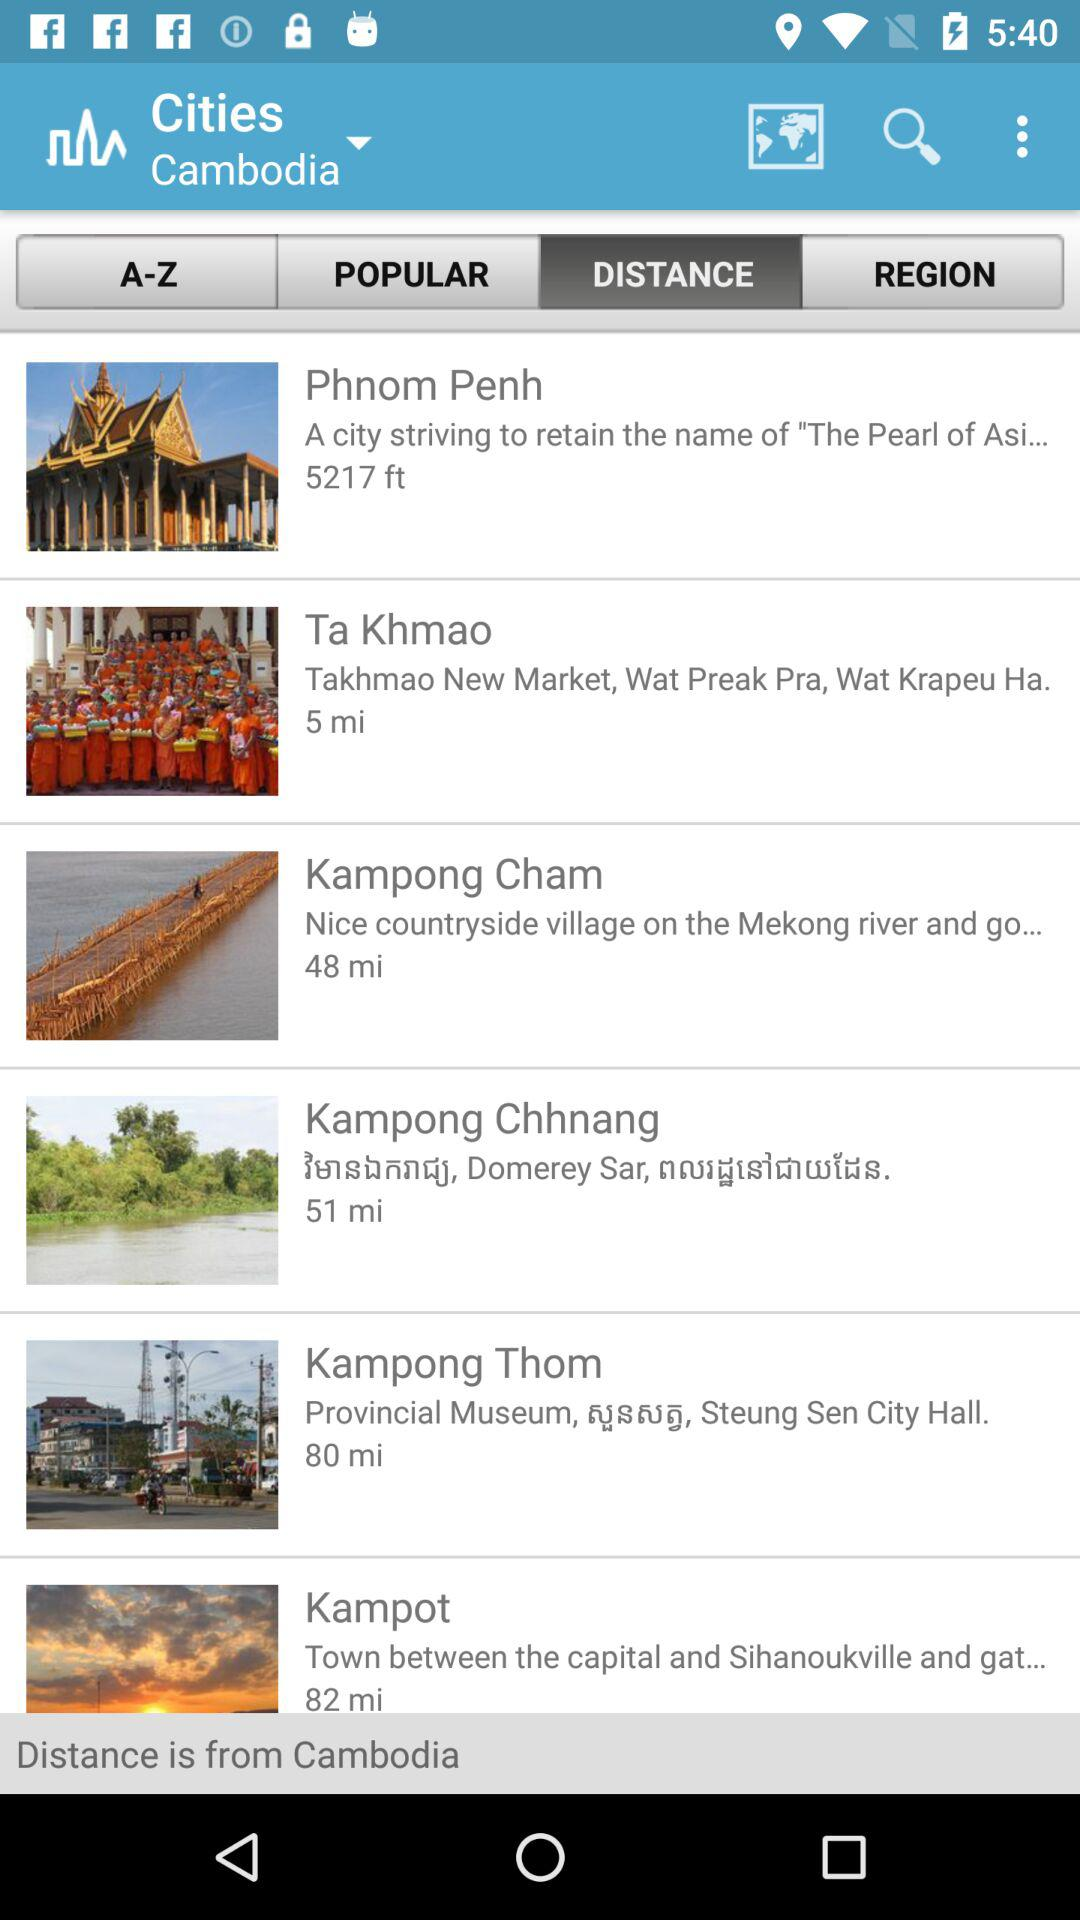Which is the name of the country from which the distance is given? The name of the country is Cambodia. 